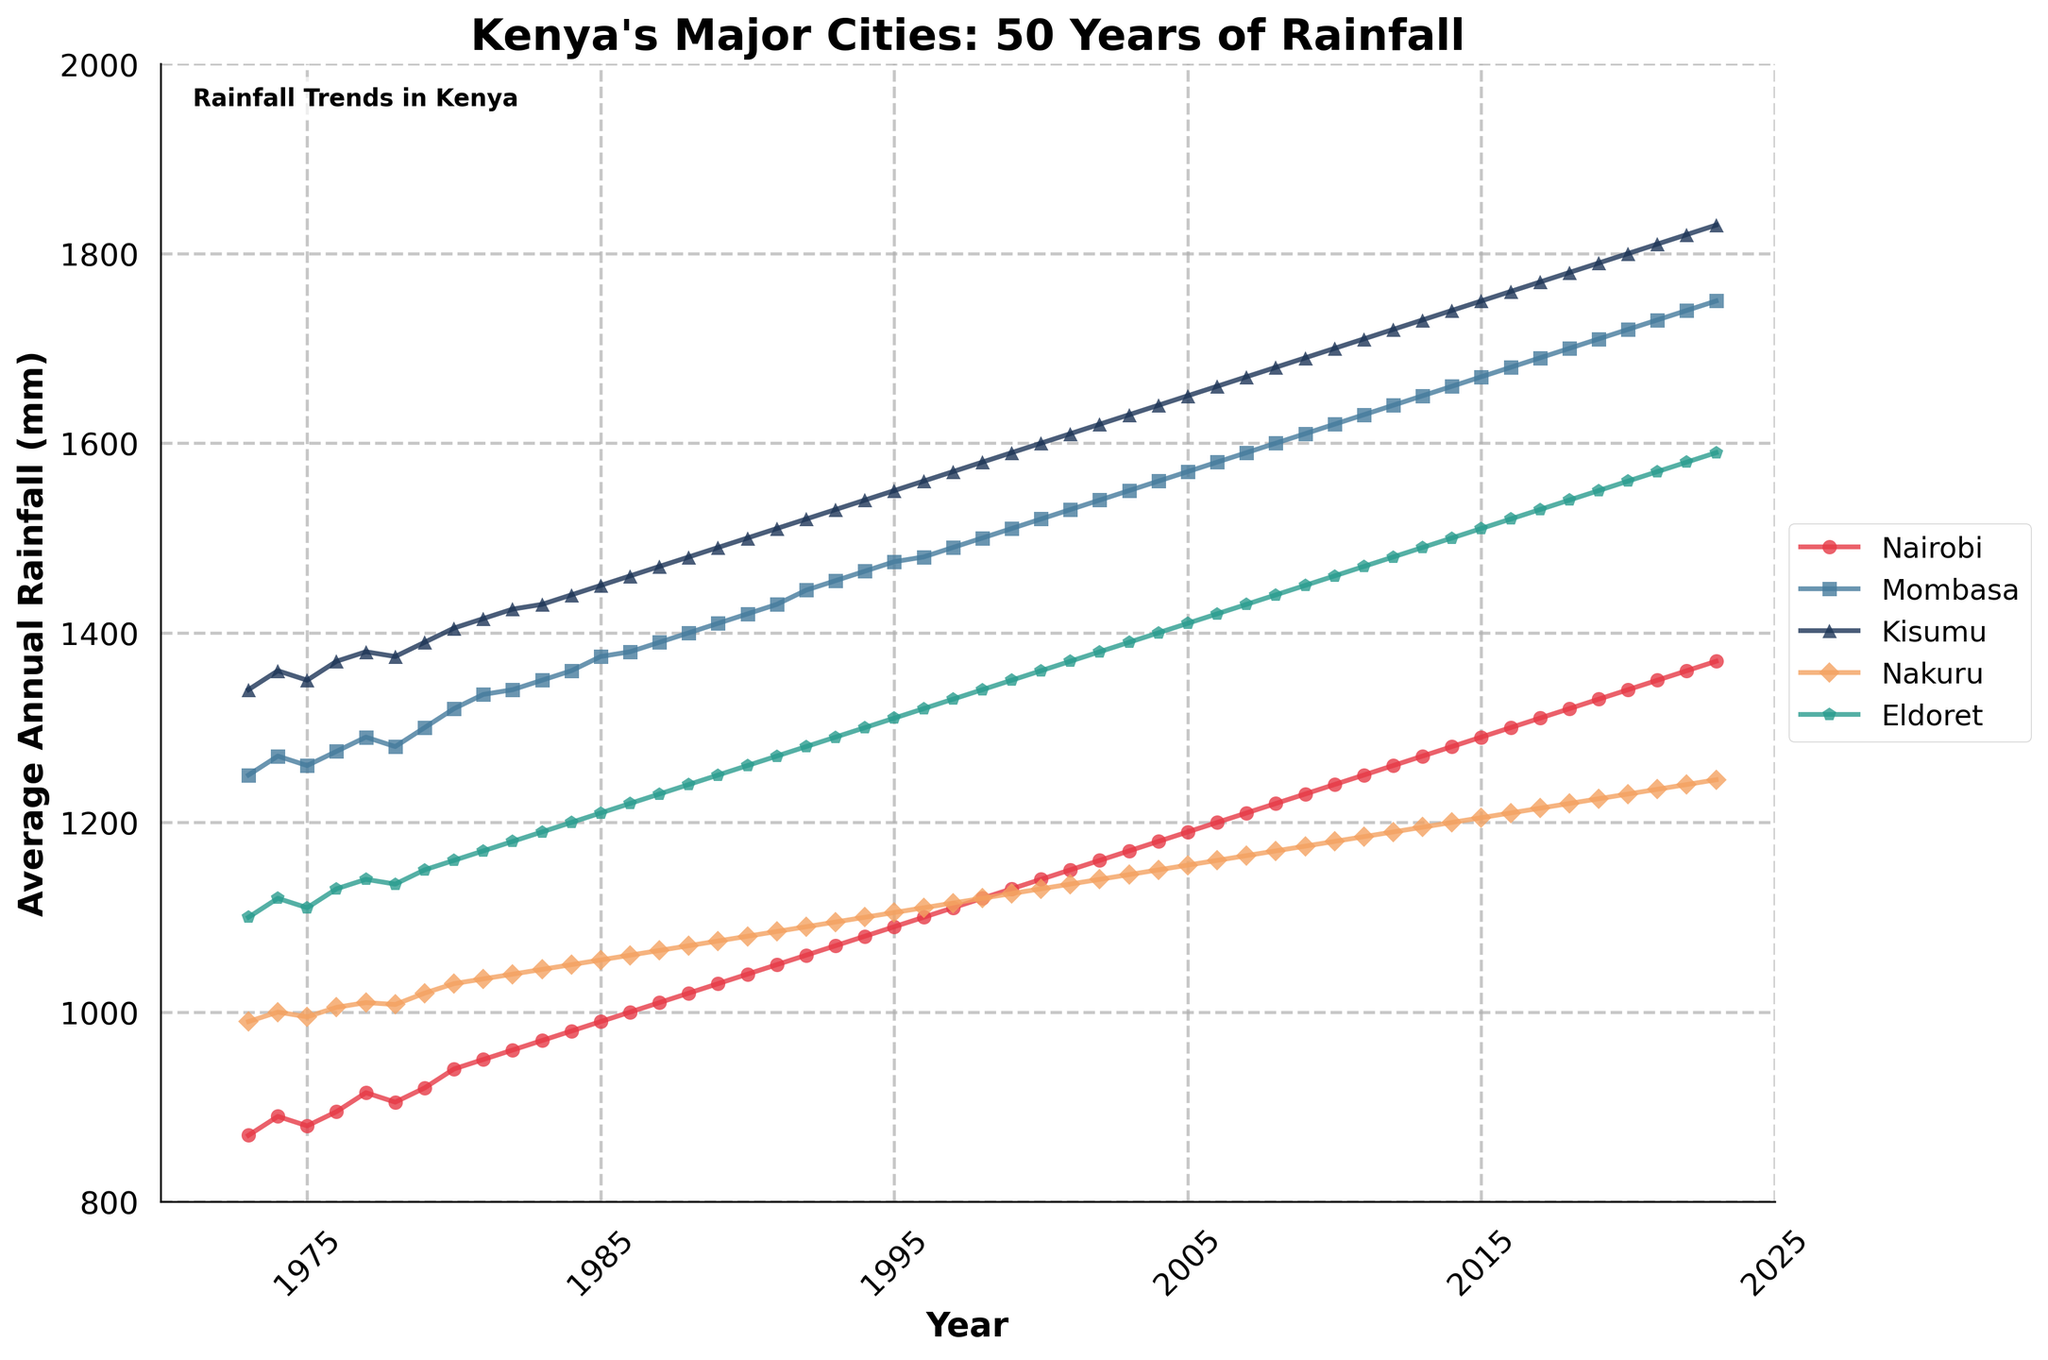What is the title of the figure? The title is generally located at the top of the figure. Here, it states "Kenya's Major Cities: 50 Years of Rainfall."
Answer: Kenya's Major Cities: 50 Years of Rainfall Which city had the lowest average annual rainfall in 1973? To answer this, look at the year 1973 on the x-axis and identify the city corresponding to the lowest y-axis value (average annual rainfall). From the data, Nairobi had the lowest value.
Answer: Nairobi How has the rainfall in Mombasa changed over 50 years? Identify the trend line for Mombasa. The y-values associated with the Mombasa line start at 1250 mm in 1973 and end at 1750 mm in 2023, indicating an upward trend.
Answer: Increased Which city had the highest average annual rainfall in 1985? Find the year 1985 on the x-axis, and then look at the y-values to find the highest one. From the data, Kisumu had the highest value.
Answer: Kisumu Between 1995 and 2005, which city saw the greatest increase in average annual rainfall? Calculate the difference in rainfall for each city between 1995 and 2005. From the data: 
Nairobi: (1190 - 1090) = 100
Mombasa: (1570 - 1475) = 95
Kisumu: (1650 - 1550) = 100
Nakuru: (1155 - 1105) = 50
Eldoret: (1410 - 1310) = 100
All differences are equal at 100 mm.
Answer: Nairobi, Kisumu, and Eldoret Has the average annual rainfall in Eldoret ever surpassed 1500 mm? Look for the maximum y-value associated with Eldoret's line. The highest value for Eldoret by 2023 is 1590 mm, which surpasses 1500 mm.
Answer: Yes What is the overall trend in average annual rainfall for the city of Nakuru? Observe Nakuru's line from 1973 to 2023; it shows a general increase from around 990 mm to 1245 mm.
Answer: Increasing Which city's rainfall trend line appears the steepest over the entire period? The steepness can be visually assessed by comparing the slope of the lines. Kisumu's trend shows the steepest rise from 1340 mm in 1973 to 1830 mm in 2023.
Answer: Kisumu What is the approximate difference in average annual rainfall between Nairobi and Kisumu in the year 2020? In 2020, Nairobi has about 1340 mm and Kisumu about 1800 mm, making the difference roughly 460 mm.
Answer: 460 mm Did any city's annual rainfall decrease from 1980 to 1985? Compare the y-values for each city's 1980 and 1985 markers. All cities show an increase or constant trend during this period.
Answer: No 